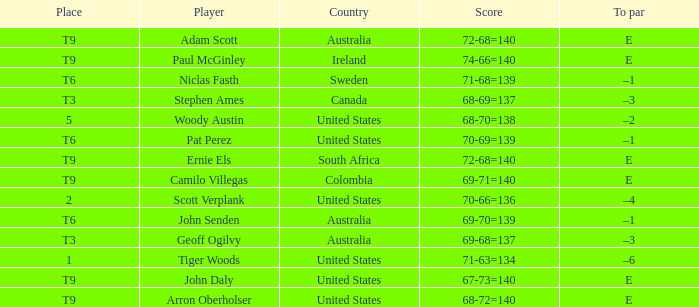What country is Adam Scott from? Australia. 